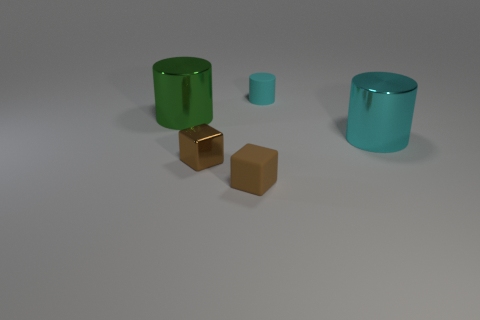Is the small shiny block the same color as the tiny rubber block? While the two blocks may appear similar in color at a glance, upon closer inspection, you will notice subtle differences in their hues and finishes. The shine on the smaller block suggests it might reflect light differently compared to the tiny rubber block which has a matte finish, thus affecting the perception of their colors. 